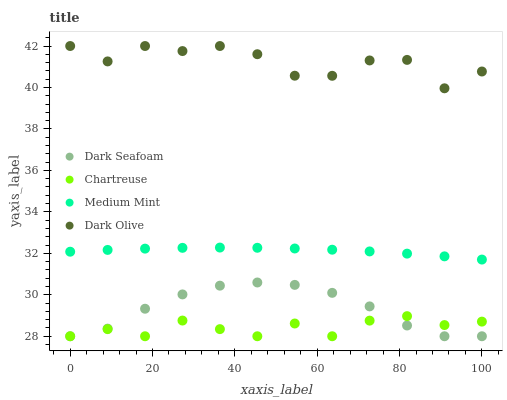Does Chartreuse have the minimum area under the curve?
Answer yes or no. Yes. Does Dark Olive have the maximum area under the curve?
Answer yes or no. Yes. Does Dark Seafoam have the minimum area under the curve?
Answer yes or no. No. Does Dark Seafoam have the maximum area under the curve?
Answer yes or no. No. Is Medium Mint the smoothest?
Answer yes or no. Yes. Is Dark Olive the roughest?
Answer yes or no. Yes. Is Dark Seafoam the smoothest?
Answer yes or no. No. Is Dark Seafoam the roughest?
Answer yes or no. No. Does Dark Seafoam have the lowest value?
Answer yes or no. Yes. Does Dark Olive have the lowest value?
Answer yes or no. No. Does Dark Olive have the highest value?
Answer yes or no. Yes. Does Dark Seafoam have the highest value?
Answer yes or no. No. Is Chartreuse less than Dark Olive?
Answer yes or no. Yes. Is Dark Olive greater than Chartreuse?
Answer yes or no. Yes. Does Dark Seafoam intersect Chartreuse?
Answer yes or no. Yes. Is Dark Seafoam less than Chartreuse?
Answer yes or no. No. Is Dark Seafoam greater than Chartreuse?
Answer yes or no. No. Does Chartreuse intersect Dark Olive?
Answer yes or no. No. 